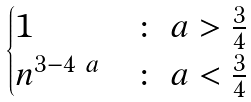Convert formula to latex. <formula><loc_0><loc_0><loc_500><loc_500>\begin{cases} 1 & \colon \ a > \frac { 3 } { 4 } \\ n ^ { 3 - 4 \ a } & \colon \ a < \frac { 3 } { 4 } \end{cases}</formula> 